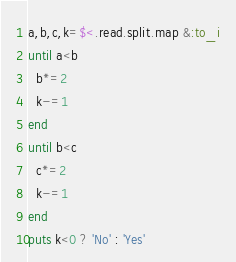Convert code to text. <code><loc_0><loc_0><loc_500><loc_500><_Ruby_>a,b,c,k=$<.read.split.map &:to_i
until a<b
  b*=2
  k-=1
end
until b<c
  c*=2
  k-=1
end
puts k<0 ? 'No' : 'Yes'
</code> 